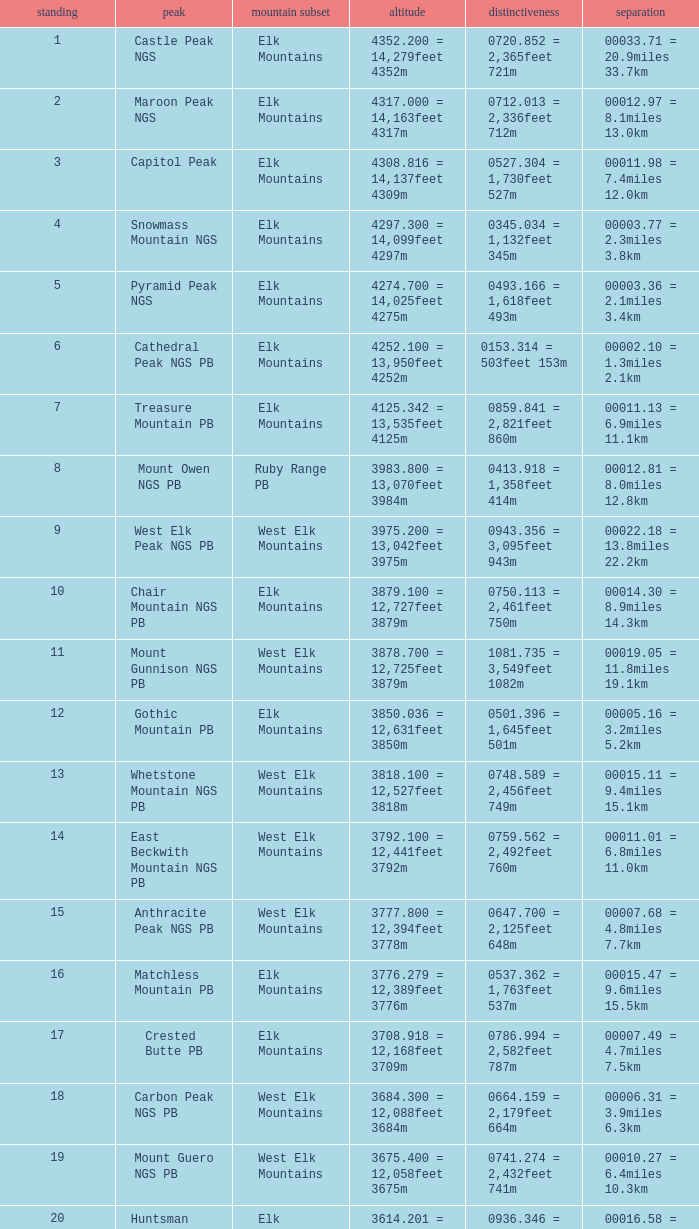Name the Rank of Rank Mountain Peak of crested butte pb? 17.0. 